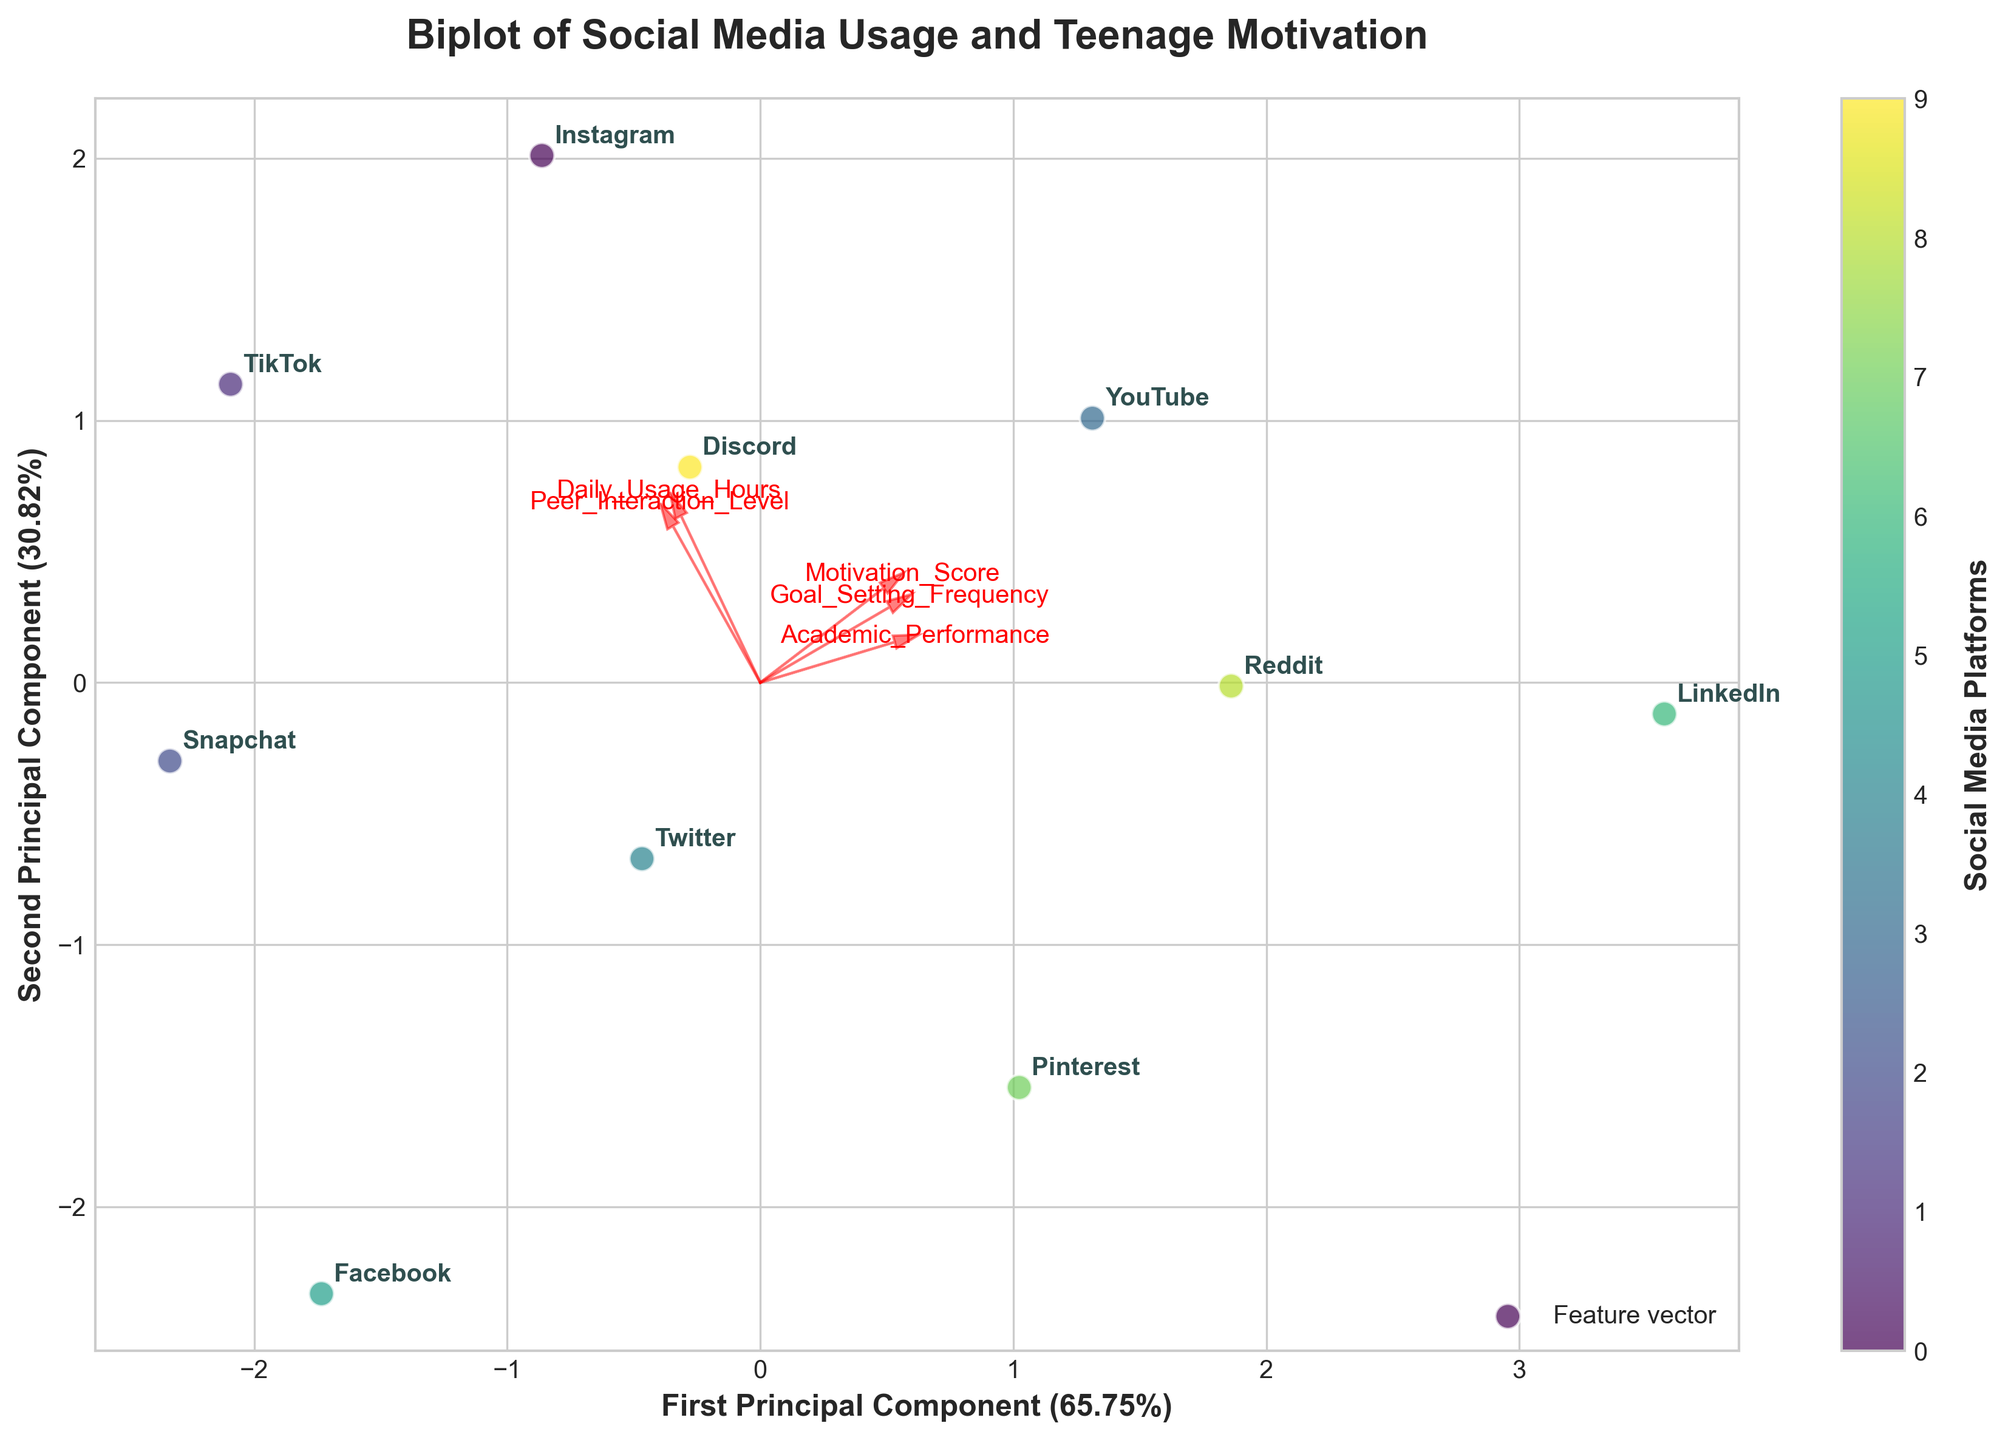How many social media platforms are represented in the plot? The biplot typically has one data point for each social media platform, and each is annotated clearly in the plot. Simply count the distinct labels.
Answer: 10 What does the title of the plot indicate about the study? The title of the plot is "Biplot of Social Media Usage and Teenage Motivation." It implies that the plot visualizes the relationship between social media usage and motivation levels among teenagers.
Answer: It shows the relationship between social media usage and teenage motivation Which social media platform has the highest motivation score? In the biplot, the platform's label should be closest to the direction of the "Motivation_Score" feature vector. Identify the platform located farthest along that vector direction.
Answer: LinkedIn How do Daily Usage Hours generally correlate with Motivation Score based on feature vectors? The direction and magnitude of the feature vectors for “Daily_Usage_Hours” and “Motivation_Score” indicate their correlation. If the vectors point in similar directions, they are positively correlated; if they point in opposite directions, they are negatively correlated.
Answer: They point in slightly different directions, indicating a weak correlation Which two platforms are closest to each other in terms of their principal components? Find the two social media platforms with the smallest Euclidean distance between their data points in the biplot.
Answer: Snapchat and Pinterest Among the platforms, which shows the highest academic performance based on the biplot? The platform label closest to the direction of the “Academic_Performance” feature vector indicates the highest academic performance.
Answer: LinkedIn How does Peer Interaction Level correlate with Goal Setting Frequency? Examine the direction and angles between the feature vectors for "Peer_Interaction_Level" and "Goal_Setting_Frequency." Vectors pointing in similar directions show a positive correlation.
Answer: Positive correlation Are Daily Usage Hours for Instagram higher or lower compared to YouTube? Refer to the actual positions of Instagram and YouTube points and consider the "Daily_Usage_Hours" feature vector. The platform closer to the vector's positive direction has higher usage hours.
Answer: Higher What principal component explains the majority of the variance in the data? Look at the labels on the axes for the percentage explained by each principal component. The axis with the higher percentage explains more variance.
Answer: First Principal Component Which platform shows a more balanced performance across all features, and how can you tell? A platform will appear closer to the origin if it has more balanced feature scores. This requires observing which labeled points are nearest to the origin.
Answer: Discord 